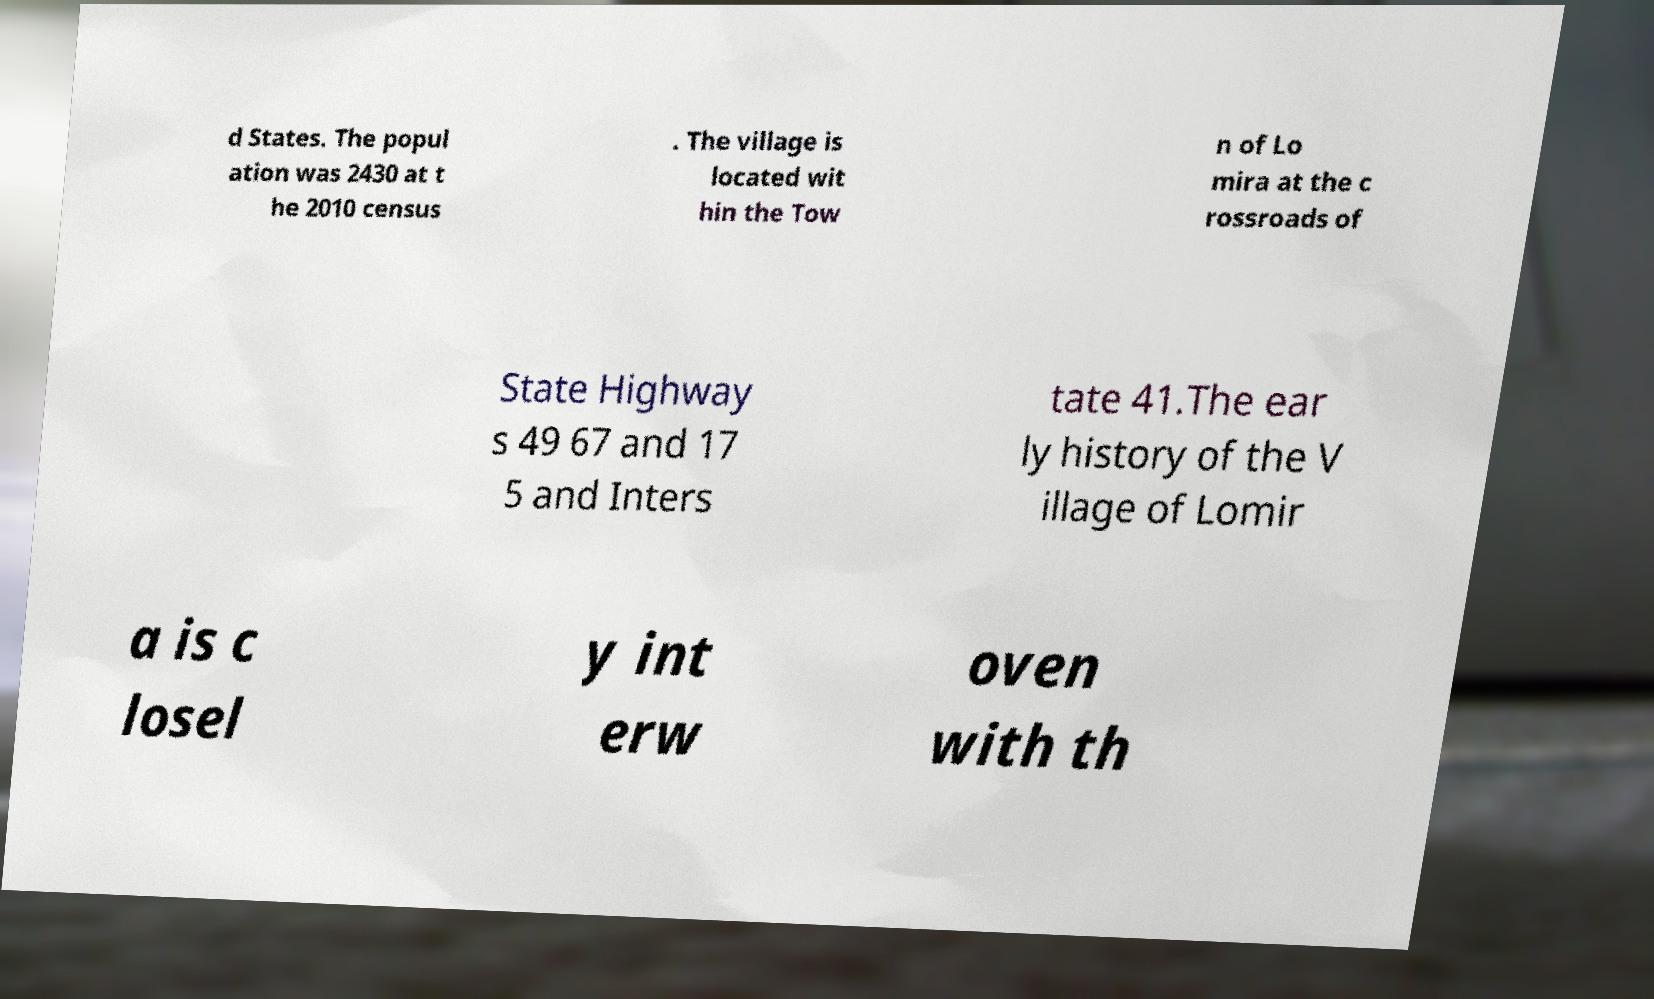There's text embedded in this image that I need extracted. Can you transcribe it verbatim? d States. The popul ation was 2430 at t he 2010 census . The village is located wit hin the Tow n of Lo mira at the c rossroads of State Highway s 49 67 and 17 5 and Inters tate 41.The ear ly history of the V illage of Lomir a is c losel y int erw oven with th 